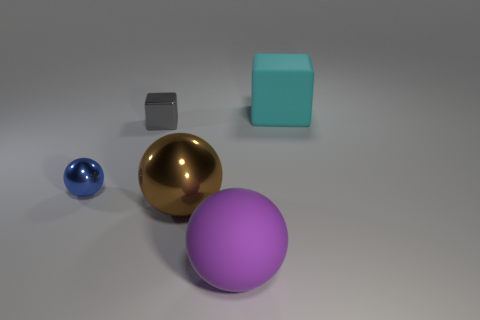Add 3 purple metal cylinders. How many objects exist? 8 Subtract all spheres. How many objects are left? 2 Add 5 cyan cylinders. How many cyan cylinders exist? 5 Subtract 1 gray cubes. How many objects are left? 4 Subtract all small gray shiny things. Subtract all big purple matte spheres. How many objects are left? 3 Add 5 blue shiny balls. How many blue shiny balls are left? 6 